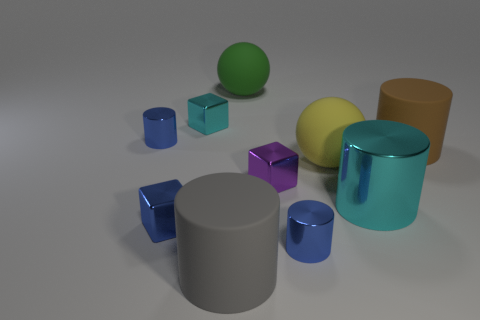Is there a purple thing that has the same material as the large cyan cylinder?
Give a very brief answer. Yes. Is the number of cyan things behind the big cyan cylinder less than the number of big cyan shiny cylinders?
Provide a succinct answer. No. There is a cyan shiny thing that is on the left side of the yellow matte ball; is its size the same as the tiny purple metallic object?
Offer a very short reply. Yes. What number of big yellow matte objects are the same shape as the big cyan object?
Offer a very short reply. 0. There is a yellow ball that is made of the same material as the large brown cylinder; what size is it?
Ensure brevity in your answer.  Large. Is the number of small cyan blocks that are to the right of the big green object the same as the number of big matte cylinders?
Your response must be concise. No. Is the shape of the brown thing that is on the right side of the purple metallic block the same as the cyan shiny thing that is behind the large cyan object?
Keep it short and to the point. No. What is the material of the gray object that is the same shape as the large brown matte thing?
Your answer should be very brief. Rubber. There is a metal thing that is both in front of the large brown matte object and behind the large metal object; what color is it?
Your response must be concise. Purple. There is a tiny shiny cylinder in front of the matte cylinder that is behind the tiny purple thing; is there a tiny blue thing left of it?
Offer a very short reply. Yes. 